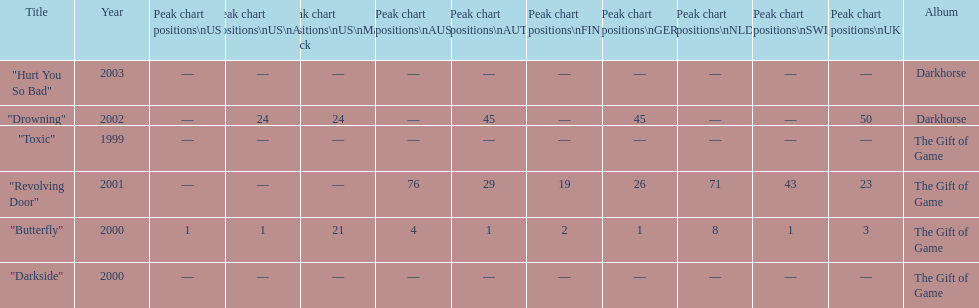Help me parse the entirety of this table. {'header': ['Title', 'Year', 'Peak chart positions\\nUS', 'Peak chart positions\\nUS\\nAlt.', 'Peak chart positions\\nUS\\nMain. Rock', 'Peak chart positions\\nAUS', 'Peak chart positions\\nAUT', 'Peak chart positions\\nFIN', 'Peak chart positions\\nGER', 'Peak chart positions\\nNLD', 'Peak chart positions\\nSWI', 'Peak chart positions\\nUK', 'Album'], 'rows': [['"Hurt You So Bad"', '2003', '—', '—', '—', '—', '—', '—', '—', '—', '—', '—', 'Darkhorse'], ['"Drowning"', '2002', '—', '24', '24', '—', '45', '—', '45', '—', '—', '50', 'Darkhorse'], ['"Toxic"', '1999', '—', '—', '—', '—', '—', '—', '—', '—', '—', '—', 'The Gift of Game'], ['"Revolving Door"', '2001', '—', '—', '—', '76', '29', '19', '26', '71', '43', '23', 'The Gift of Game'], ['"Butterfly"', '2000', '1', '1', '21', '4', '1', '2', '1', '8', '1', '3', 'The Gift of Game'], ['"Darkside"', '2000', '—', '—', '—', '—', '—', '—', '—', '—', '—', '—', 'The Gift of Game']]} Which single ranks 1 in us and 1 in us alt? "Butterfly". 